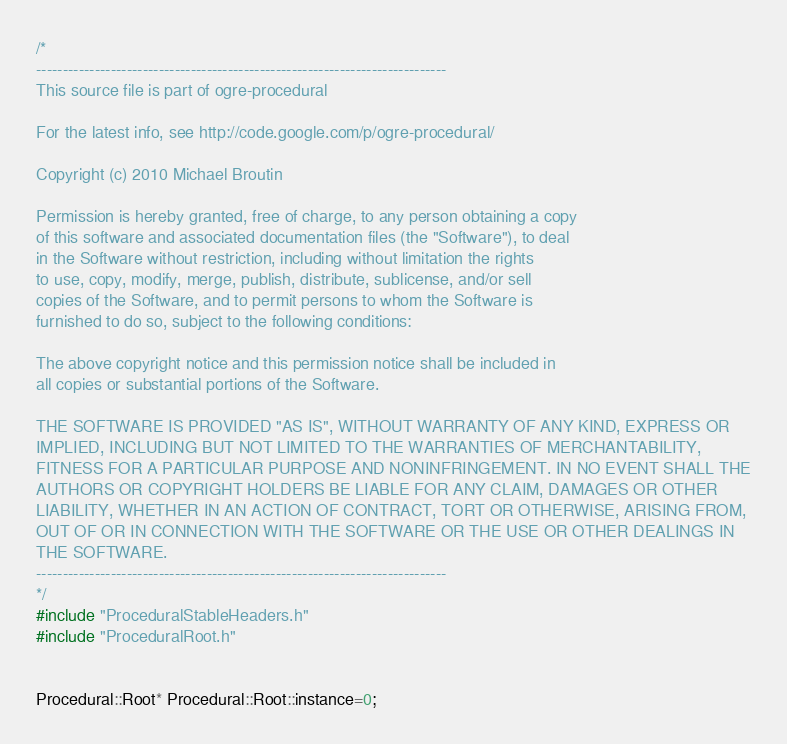<code> <loc_0><loc_0><loc_500><loc_500><_C++_>/*
-----------------------------------------------------------------------------
This source file is part of ogre-procedural

For the latest info, see http://code.google.com/p/ogre-procedural/

Copyright (c) 2010 Michael Broutin

Permission is hereby granted, free of charge, to any person obtaining a copy
of this software and associated documentation files (the "Software"), to deal
in the Software without restriction, including without limitation the rights
to use, copy, modify, merge, publish, distribute, sublicense, and/or sell
copies of the Software, and to permit persons to whom the Software is
furnished to do so, subject to the following conditions:

The above copyright notice and this permission notice shall be included in
all copies or substantial portions of the Software.

THE SOFTWARE IS PROVIDED "AS IS", WITHOUT WARRANTY OF ANY KIND, EXPRESS OR
IMPLIED, INCLUDING BUT NOT LIMITED TO THE WARRANTIES OF MERCHANTABILITY,
FITNESS FOR A PARTICULAR PURPOSE AND NONINFRINGEMENT. IN NO EVENT SHALL THE
AUTHORS OR COPYRIGHT HOLDERS BE LIABLE FOR ANY CLAIM, DAMAGES OR OTHER
LIABILITY, WHETHER IN AN ACTION OF CONTRACT, TORT OR OTHERWISE, ARISING FROM,
OUT OF OR IN CONNECTION WITH THE SOFTWARE OR THE USE OR OTHER DEALINGS IN
THE SOFTWARE.
-----------------------------------------------------------------------------
*/
#include "ProceduralStableHeaders.h"
#include "ProceduralRoot.h"


Procedural::Root* Procedural::Root::instance=0;
</code> 